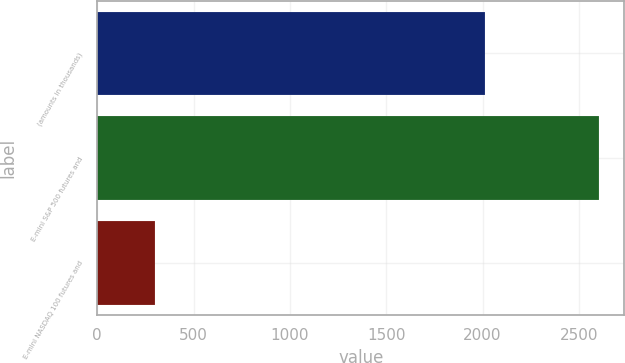Convert chart. <chart><loc_0><loc_0><loc_500><loc_500><bar_chart><fcel>(amounts in thousands)<fcel>E-mini S&P 500 futures and<fcel>E-mini NASDAQ 100 futures and<nl><fcel>2011<fcel>2605<fcel>301<nl></chart> 